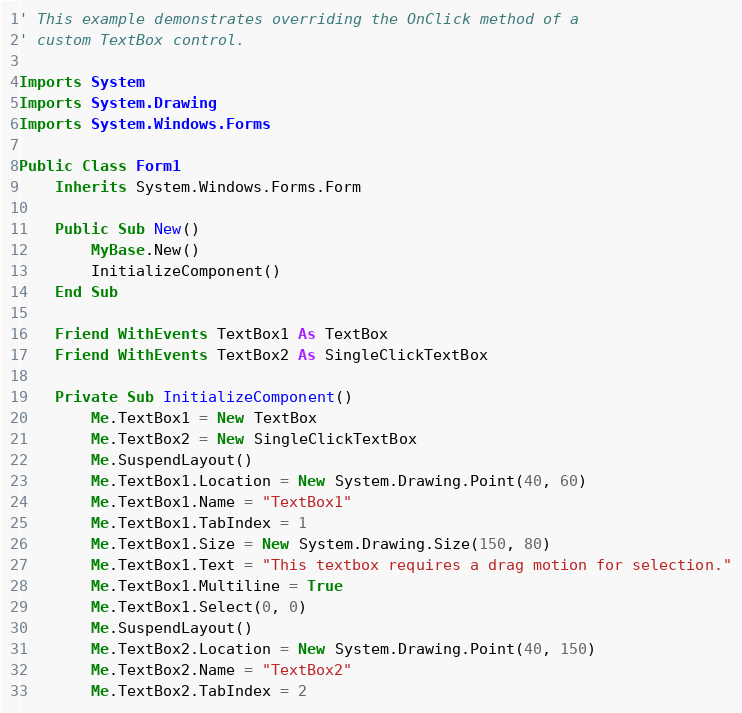Convert code to text. <code><loc_0><loc_0><loc_500><loc_500><_VisualBasic_>' This example demonstrates overriding the OnClick method of a 
' custom TextBox control.

Imports System
Imports System.Drawing
Imports System.Windows.Forms

Public Class Form1
    Inherits System.Windows.Forms.Form

    Public Sub New()
        MyBase.New()
        InitializeComponent()
    End Sub

    Friend WithEvents TextBox1 As TextBox
    Friend WithEvents TextBox2 As SingleClickTextBox

    Private Sub InitializeComponent()
        Me.TextBox1 = New TextBox
        Me.TextBox2 = New SingleClickTextBox
        Me.SuspendLayout()
        Me.TextBox1.Location = New System.Drawing.Point(40, 60)
        Me.TextBox1.Name = "TextBox1"
        Me.TextBox1.TabIndex = 1
        Me.TextBox1.Size = New System.Drawing.Size(150, 80)
        Me.TextBox1.Text = "This textbox requires a drag motion for selection."
        Me.TextBox1.Multiline = True
        Me.TextBox1.Select(0, 0)
        Me.SuspendLayout()
        Me.TextBox2.Location = New System.Drawing.Point(40, 150)
        Me.TextBox2.Name = "TextBox2"
        Me.TextBox2.TabIndex = 2</code> 